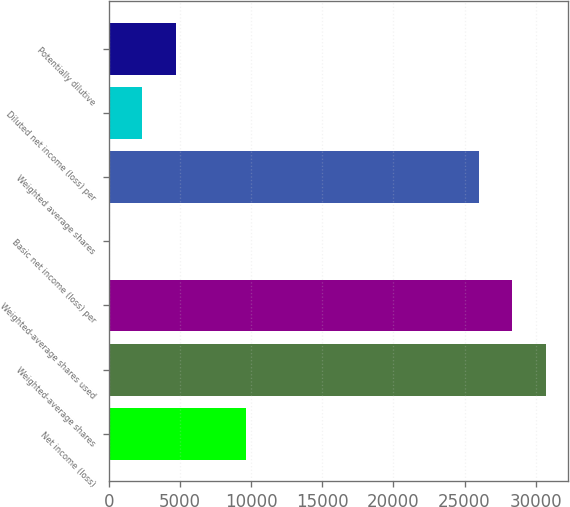Convert chart to OTSL. <chart><loc_0><loc_0><loc_500><loc_500><bar_chart><fcel>Net income (loss)<fcel>Weighted-average shares<fcel>Weighted-average shares used<fcel>Basic net income (loss) per<fcel>Weighted average shares<fcel>Diluted net income (loss) per<fcel>Potentially dilutive<nl><fcel>9623<fcel>30714.9<fcel>28351.9<fcel>0.41<fcel>25989<fcel>2363.37<fcel>4726.33<nl></chart> 